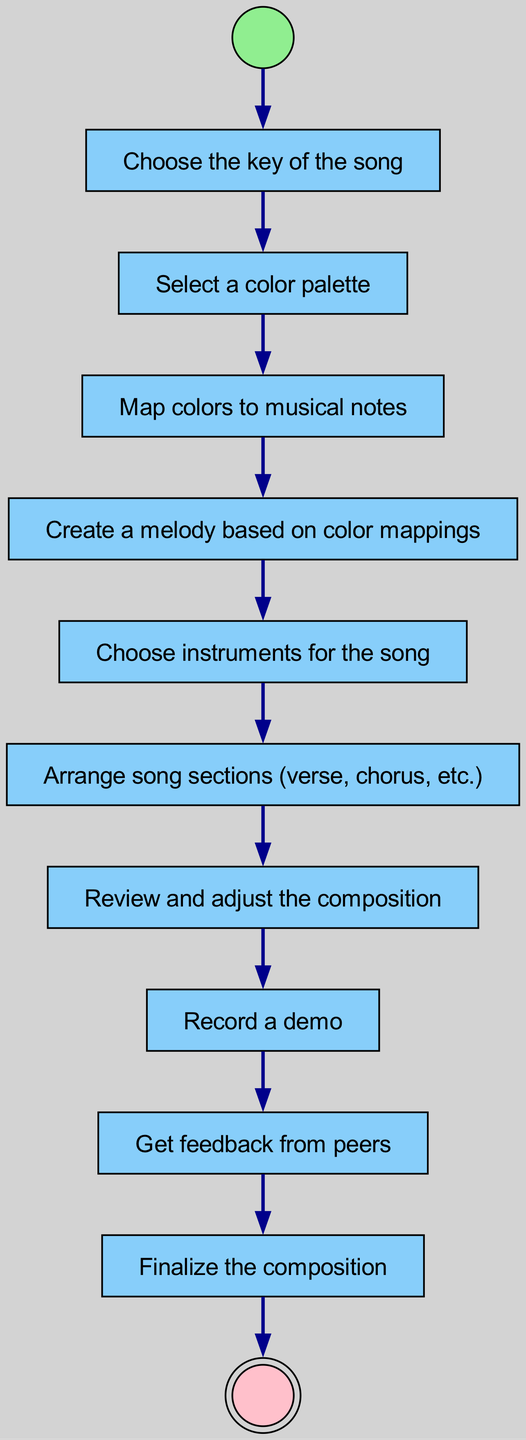What is the first action in the diagram? The first action is the one that follows the 'start' node. According to the transitions listed, after 'start', the next node is 'chooseKey', which is labeled as the action within the diagram.
Answer: Choose the key of the song How many action nodes are there in total? To determine the total number of action nodes, we can count the nodes that have the type 'action'. There are 8 action nodes listed, including 'chooseKey', 'selectColorPalette', 'mapColorsToNotes', 'createMelody', 'chooseInstrument', 'arrangeSections', 'reviewComposition', 'recordDemo', 'getFeedback', and 'finalizeComposition'.
Answer: 8 What node comes after 'arrangeSections'? The node that follows 'arrangeSections' can be found by examining the transitions. According to the transition from 'arrangeSections', the next node is 'reviewComposition'.
Answer: Review composition Which node is the last action before finalization? The last action before the 'finalizeComposition' node can be traced from the transitions. The node immediately preceding 'finalizeComposition' is 'getFeedback'.
Answer: Get feedback What type of diagram is this? The type of diagram is stated within the context of the activity. It is an 'Activity Diagram', specifically designed to map out the sequences and flow of actions involved in composing a color-themed song.
Answer: Activity Diagram How many transitions are there connecting the nodes? To find the number of transitions, count each link between the nodes as described in the transitions. There are a total of 10 transitions listed within the data provided.
Answer: 10 What is the shape of the start node? The shape of the start node is indicated in the graph identifier for the 'start' node. It specifically mentions that it is shaped like a circle.
Answer: Circle What follows the creative phase of making a melody? The phase that follows 'createMelody', which describes the action taken, can be understood by looking at the transitions. 'chooseInstrument' is the next action following 'createMelody'.
Answer: Choose instruments for the song 